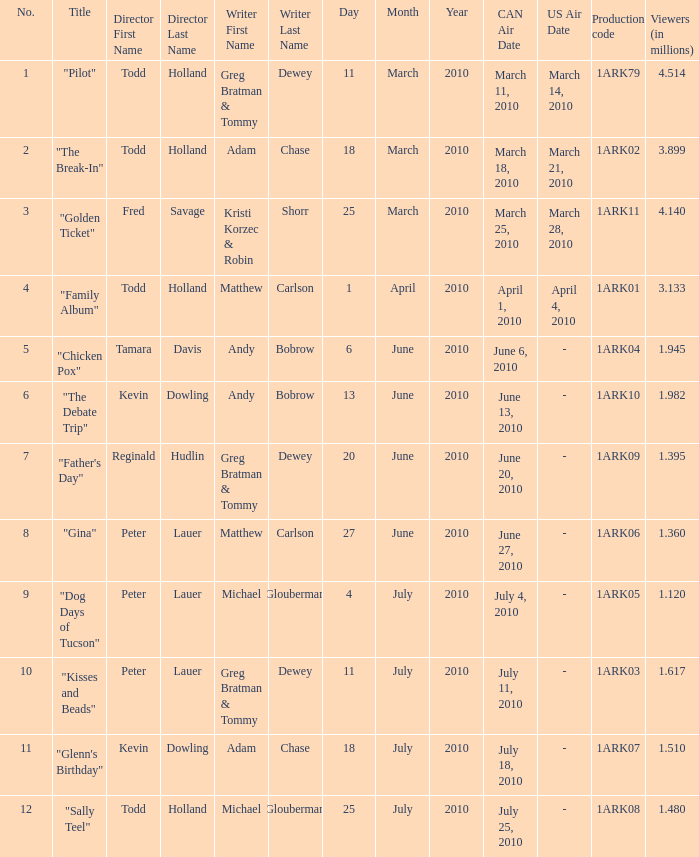List all directors from episodes with viewership of 1.945 million. Tamara Davis. 